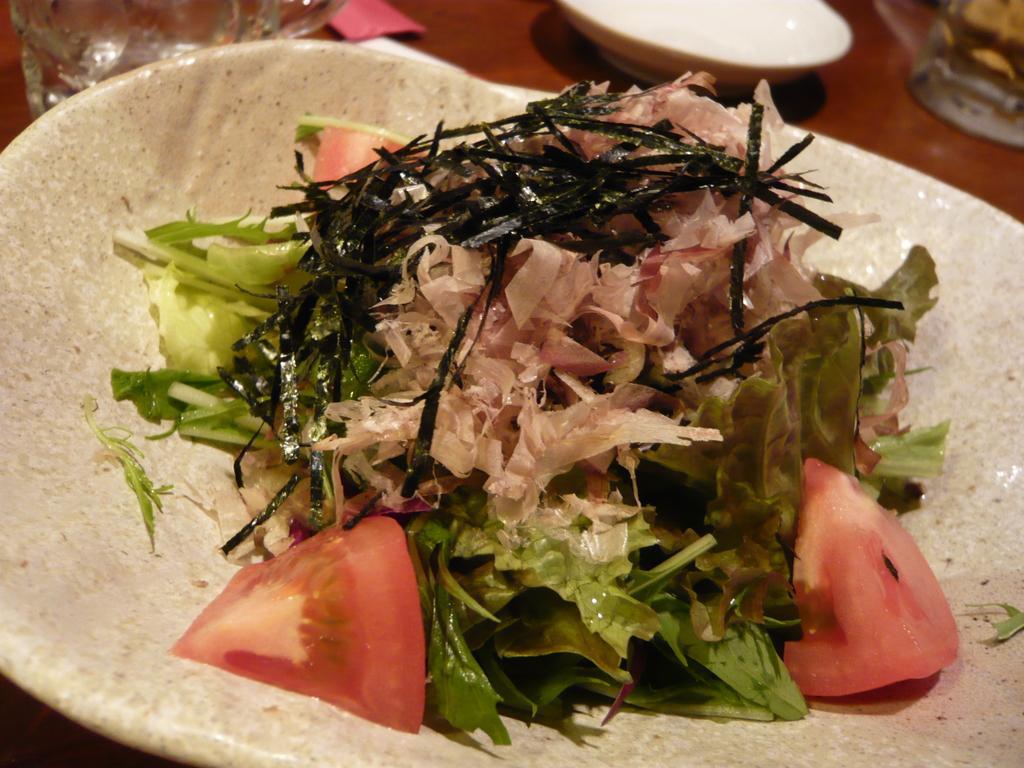In one or two sentences, can you explain what this image depicts? In this picture there is a food on plate. There is a plate, bowl and there are glasses on the table. 